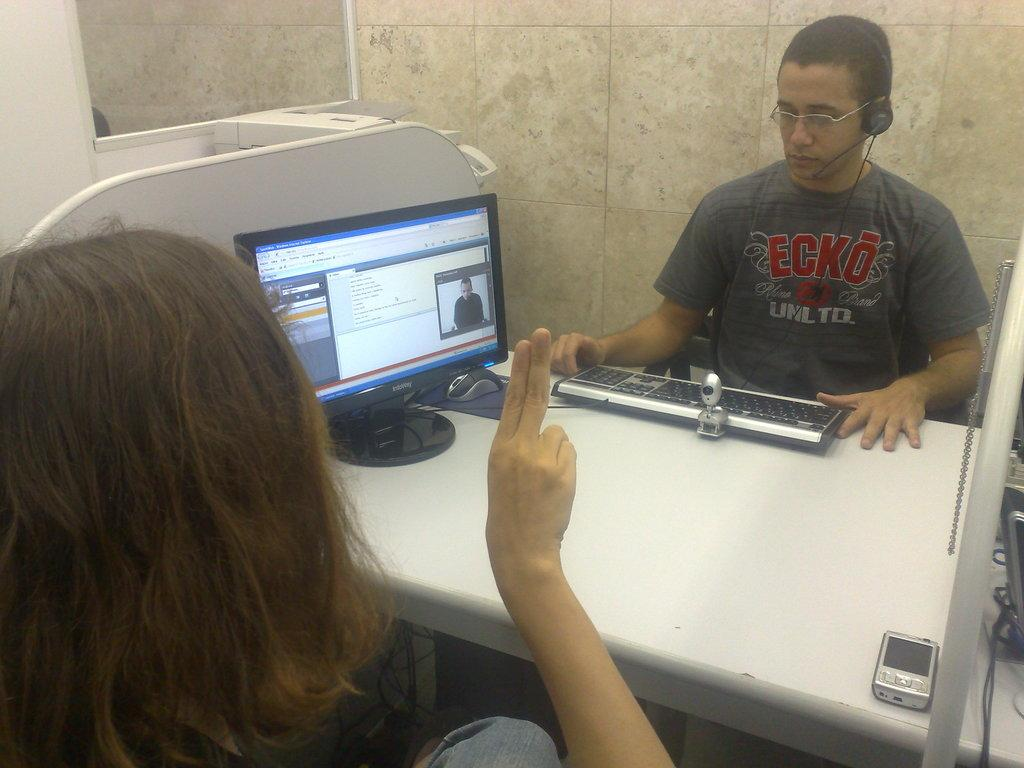<image>
Render a clear and concise summary of the photo. Two people talking over a work station with the male worker wearing a t-shirt that says Ecko. 